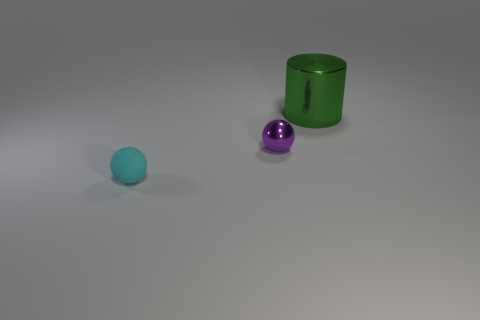Add 1 blue cubes. How many objects exist? 4 Subtract 2 spheres. How many spheres are left? 0 Subtract all cylinders. How many objects are left? 2 Subtract all yellow balls. Subtract all red cubes. How many balls are left? 2 Subtract all purple metallic things. Subtract all big brown matte cylinders. How many objects are left? 2 Add 2 big green cylinders. How many big green cylinders are left? 3 Add 2 big cylinders. How many big cylinders exist? 3 Subtract 0 purple cylinders. How many objects are left? 3 